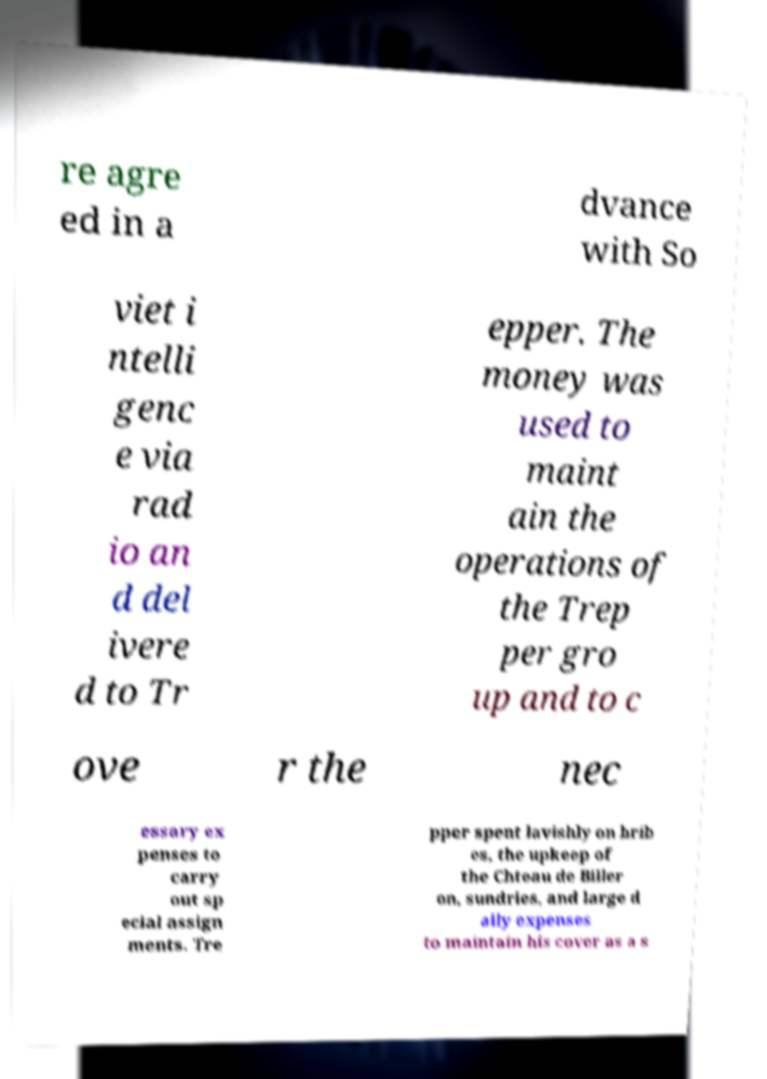Please identify and transcribe the text found in this image. re agre ed in a dvance with So viet i ntelli genc e via rad io an d del ivere d to Tr epper. The money was used to maint ain the operations of the Trep per gro up and to c ove r the nec essary ex penses to carry out sp ecial assign ments. Tre pper spent lavishly on brib es, the upkeep of the Chteau de Biller on, sundries, and large d aily expenses to maintain his cover as a s 